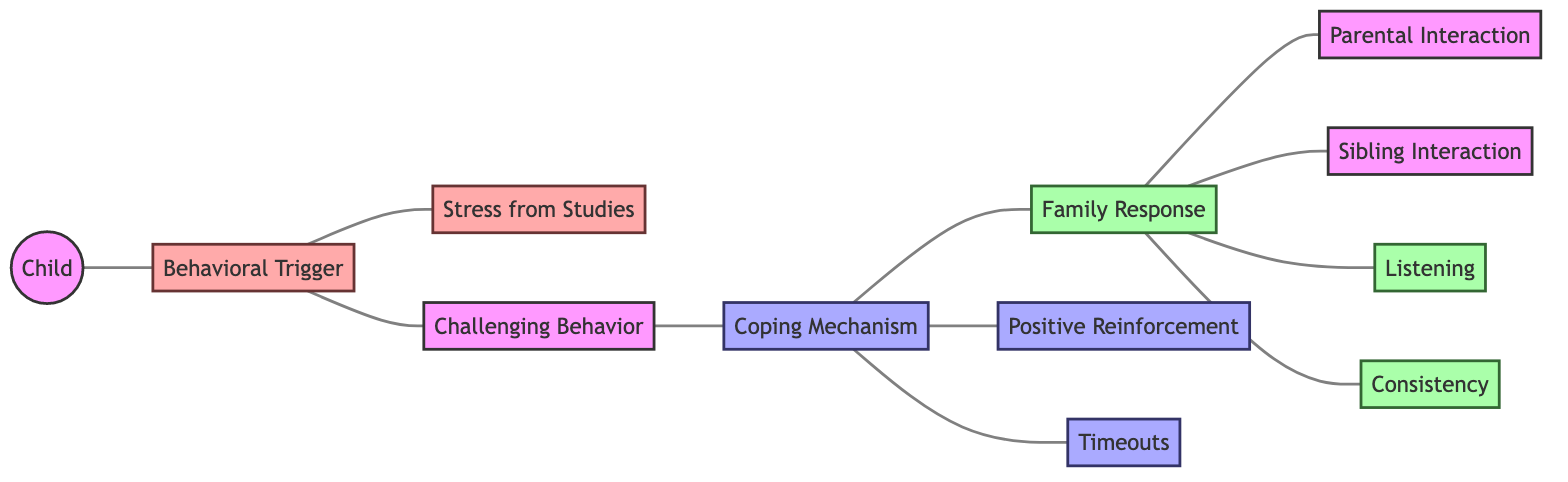What is the main subject of the diagram? The main subject is the "Child," as it is the central node from which all connections originate, indicating that the diagram focuses on the relationships and interactions involving the child's behavior.
Answer: Child How many nodes are there in the diagram? Counting all unique elements, there are 11 nodes in total, which include the child, triggers, mechanisms, and responses related to behavior.
Answer: 11 What is one coping mechanism identified in the diagram? The diagram indicates "Positive Reinforcement" as one of the coping mechanisms available for the child, showing a direct connection from coping mechanisms to family responses.
Answer: Positive Reinforcement Which family response is linked to listening? The family response tied to "Listening" is directly connected to the "Family Response" node, highlighting the importance of listening as a reaction to the child's behavior.
Answer: Listening What triggers challenging behavior in the child? "Behavioral Trigger" is the node directly pointing to "Challenging Behavior," suggesting that various triggers contribute to this behavior in the child.
Answer: Behavioral Trigger How many coping mechanisms are shown in the diagram? There are three coping mechanisms represented in the diagram: "Positive Reinforcement," "Timeouts," and a general link from "Coping Mechanism" to "Family Response," suggesting other potential responses.
Answer: 3 What response is connected to both parental and sibling interactions? The "Family Response" node connects to both "Parental Interaction" and "Sibling Interaction," indicating that family interactions are part of how responses are formed in relation to the child's behavior.
Answer: Family Response Which behavioral trigger is specified in the diagram? "Stress from Studies" is explicitly mentioned as a behavioral trigger, showing how academic pressure can affect the child's behavior.
Answer: Stress from Studies What connection does "Consistency" have in the diagram? "Consistency" is categorized as a family response, showing its importance in managing the child's behavior effectively according to the diagram's structure.
Answer: Consistency 